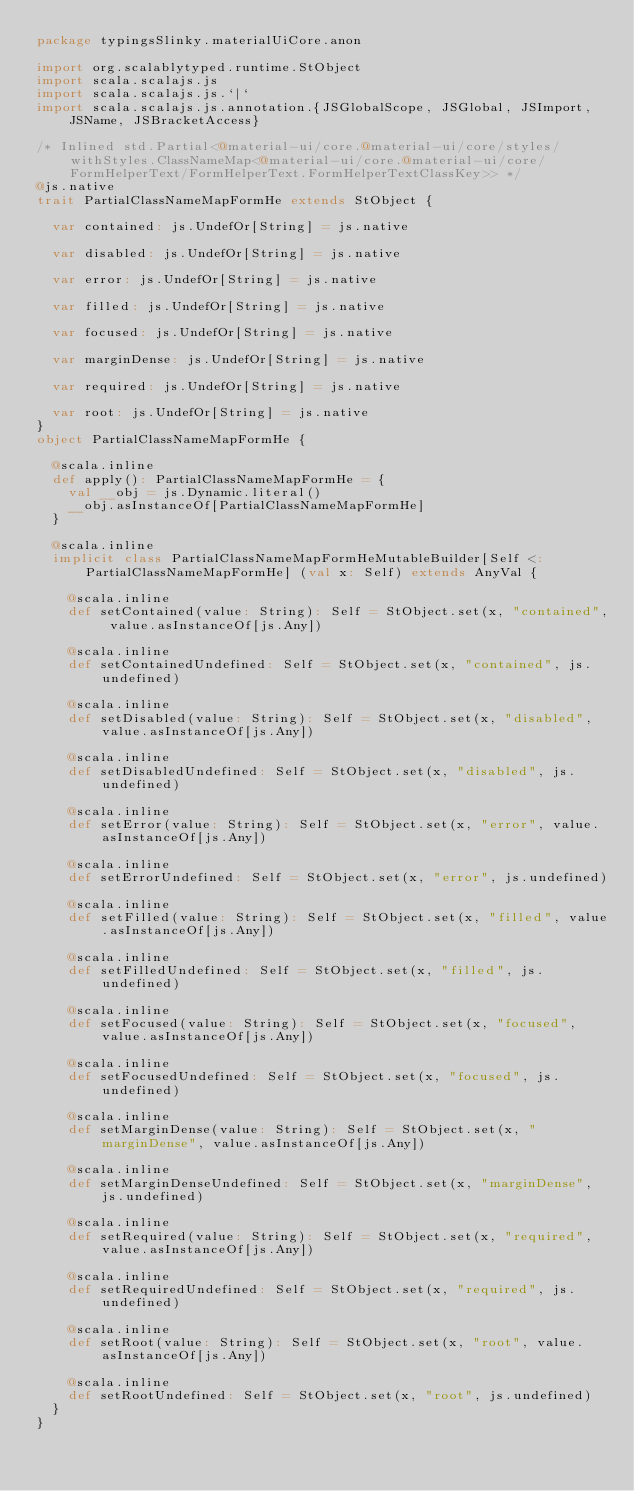Convert code to text. <code><loc_0><loc_0><loc_500><loc_500><_Scala_>package typingsSlinky.materialUiCore.anon

import org.scalablytyped.runtime.StObject
import scala.scalajs.js
import scala.scalajs.js.`|`
import scala.scalajs.js.annotation.{JSGlobalScope, JSGlobal, JSImport, JSName, JSBracketAccess}

/* Inlined std.Partial<@material-ui/core.@material-ui/core/styles/withStyles.ClassNameMap<@material-ui/core.@material-ui/core/FormHelperText/FormHelperText.FormHelperTextClassKey>> */
@js.native
trait PartialClassNameMapFormHe extends StObject {
  
  var contained: js.UndefOr[String] = js.native
  
  var disabled: js.UndefOr[String] = js.native
  
  var error: js.UndefOr[String] = js.native
  
  var filled: js.UndefOr[String] = js.native
  
  var focused: js.UndefOr[String] = js.native
  
  var marginDense: js.UndefOr[String] = js.native
  
  var required: js.UndefOr[String] = js.native
  
  var root: js.UndefOr[String] = js.native
}
object PartialClassNameMapFormHe {
  
  @scala.inline
  def apply(): PartialClassNameMapFormHe = {
    val __obj = js.Dynamic.literal()
    __obj.asInstanceOf[PartialClassNameMapFormHe]
  }
  
  @scala.inline
  implicit class PartialClassNameMapFormHeMutableBuilder[Self <: PartialClassNameMapFormHe] (val x: Self) extends AnyVal {
    
    @scala.inline
    def setContained(value: String): Self = StObject.set(x, "contained", value.asInstanceOf[js.Any])
    
    @scala.inline
    def setContainedUndefined: Self = StObject.set(x, "contained", js.undefined)
    
    @scala.inline
    def setDisabled(value: String): Self = StObject.set(x, "disabled", value.asInstanceOf[js.Any])
    
    @scala.inline
    def setDisabledUndefined: Self = StObject.set(x, "disabled", js.undefined)
    
    @scala.inline
    def setError(value: String): Self = StObject.set(x, "error", value.asInstanceOf[js.Any])
    
    @scala.inline
    def setErrorUndefined: Self = StObject.set(x, "error", js.undefined)
    
    @scala.inline
    def setFilled(value: String): Self = StObject.set(x, "filled", value.asInstanceOf[js.Any])
    
    @scala.inline
    def setFilledUndefined: Self = StObject.set(x, "filled", js.undefined)
    
    @scala.inline
    def setFocused(value: String): Self = StObject.set(x, "focused", value.asInstanceOf[js.Any])
    
    @scala.inline
    def setFocusedUndefined: Self = StObject.set(x, "focused", js.undefined)
    
    @scala.inline
    def setMarginDense(value: String): Self = StObject.set(x, "marginDense", value.asInstanceOf[js.Any])
    
    @scala.inline
    def setMarginDenseUndefined: Self = StObject.set(x, "marginDense", js.undefined)
    
    @scala.inline
    def setRequired(value: String): Self = StObject.set(x, "required", value.asInstanceOf[js.Any])
    
    @scala.inline
    def setRequiredUndefined: Self = StObject.set(x, "required", js.undefined)
    
    @scala.inline
    def setRoot(value: String): Self = StObject.set(x, "root", value.asInstanceOf[js.Any])
    
    @scala.inline
    def setRootUndefined: Self = StObject.set(x, "root", js.undefined)
  }
}
</code> 